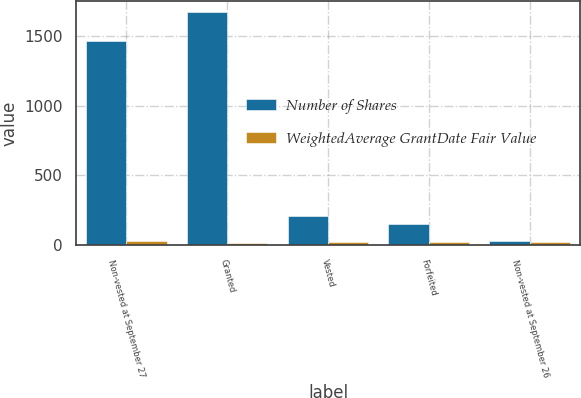<chart> <loc_0><loc_0><loc_500><loc_500><stacked_bar_chart><ecel><fcel>Non-vested at September 27<fcel>Granted<fcel>Vested<fcel>Forfeited<fcel>Non-vested at September 26<nl><fcel>Number of Shares<fcel>1461<fcel>1669<fcel>210<fcel>150<fcel>31.23<nl><fcel>WeightedAverage GrantDate Fair Value<fcel>31.23<fcel>14.46<fcel>23.87<fcel>23.44<fcel>21.96<nl></chart> 